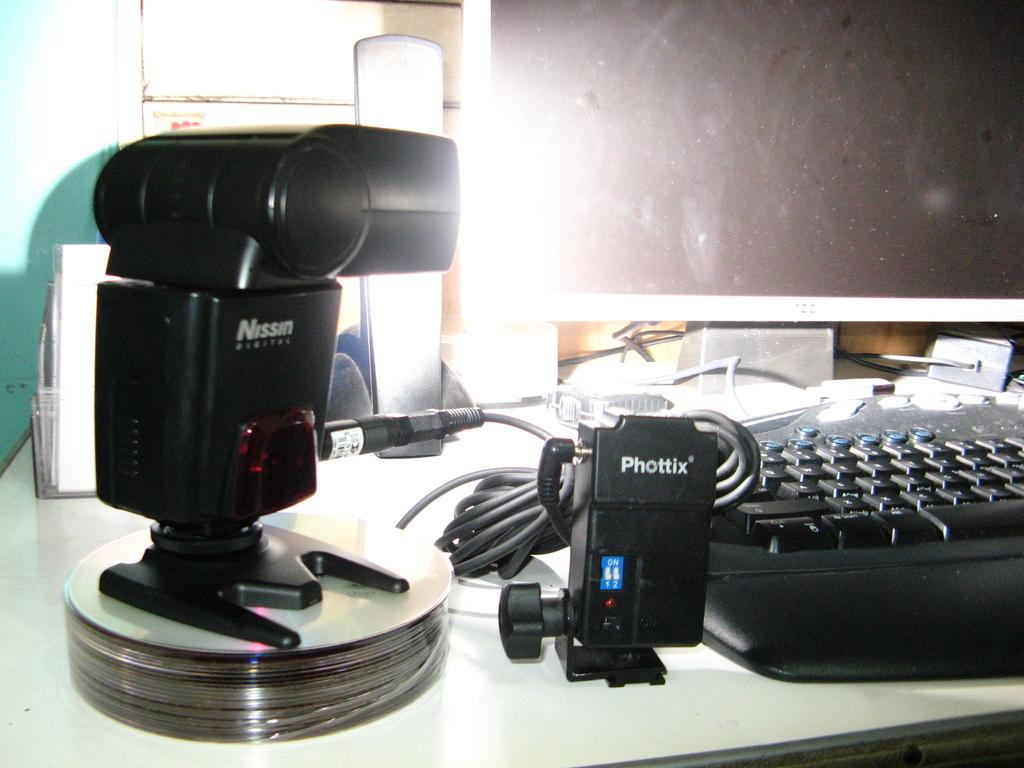<image>
Write a terse but informative summary of the picture. A black light by the brand Nissin Digital aand a camera attachment that reads Phottix 